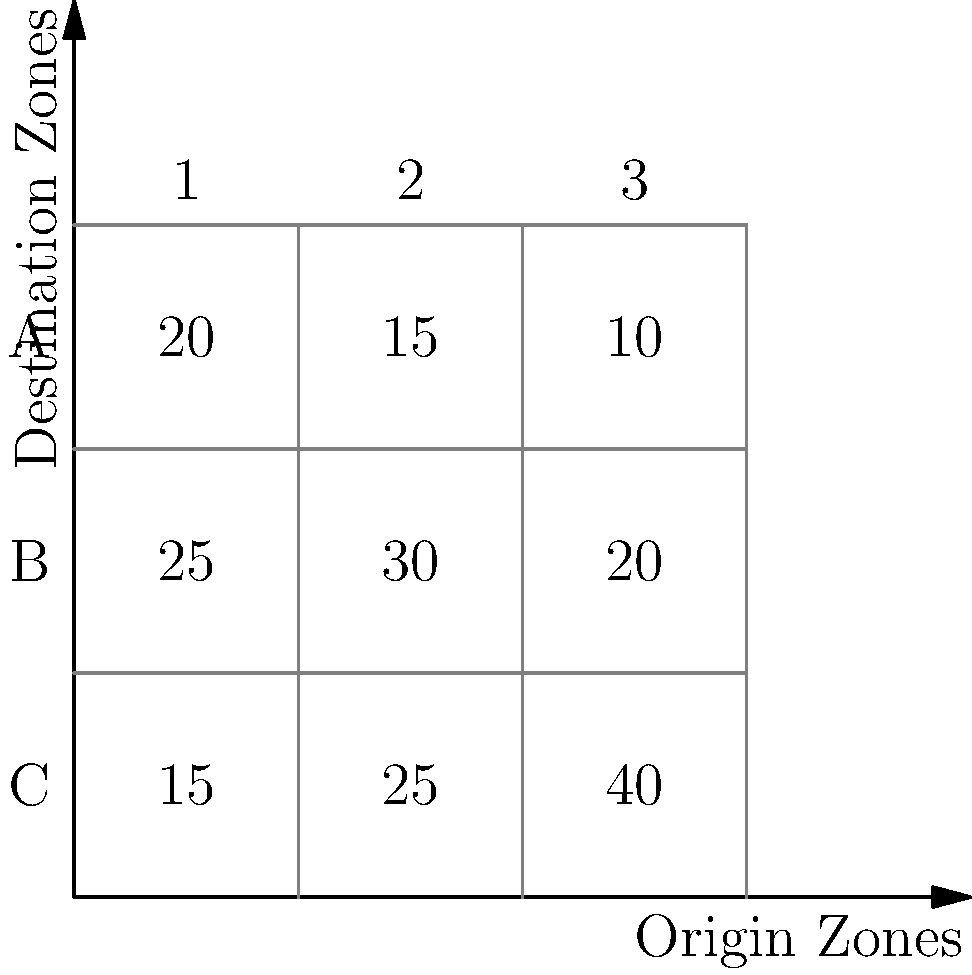Given the origin-destination (O-D) matrix shown in the image, which represents the number of trips between three origin zones (A, B, C) and three destination zones (1, 2, 3), calculate the total number of trips originating from zone B. How does this compare to the total trips destined for zone 2? To solve this problem, we need to follow these steps:

1. Identify the rows and columns in the O-D matrix:
   - Rows represent origin zones (A, B, C)
   - Columns represent destination zones (1, 2, 3)

2. Calculate the total trips originating from zone B:
   - Zone B is represented by the middle row
   - Sum the values in this row: $25 + 30 + 20 = 75$ trips

3. Calculate the total trips destined for zone 2:
   - Zone 2 is represented by the middle column
   - Sum the values in this column: $15 + 30 + 25 = 70$ trips

4. Compare the two values:
   - Trips originating from zone B: 75
   - Trips destined for zone 2: 70
   - The difference is: $75 - 70 = 5$ trips

Therefore, the total number of trips originating from zone B is 75, which is 5 more than the total trips destined for zone 2 (70).
Answer: 75 trips from B; 5 more than to zone 2 